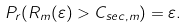<formula> <loc_0><loc_0><loc_500><loc_500>P _ { r } ( R _ { m } ( \varepsilon ) > C _ { s e c , m } ) = \varepsilon .</formula> 